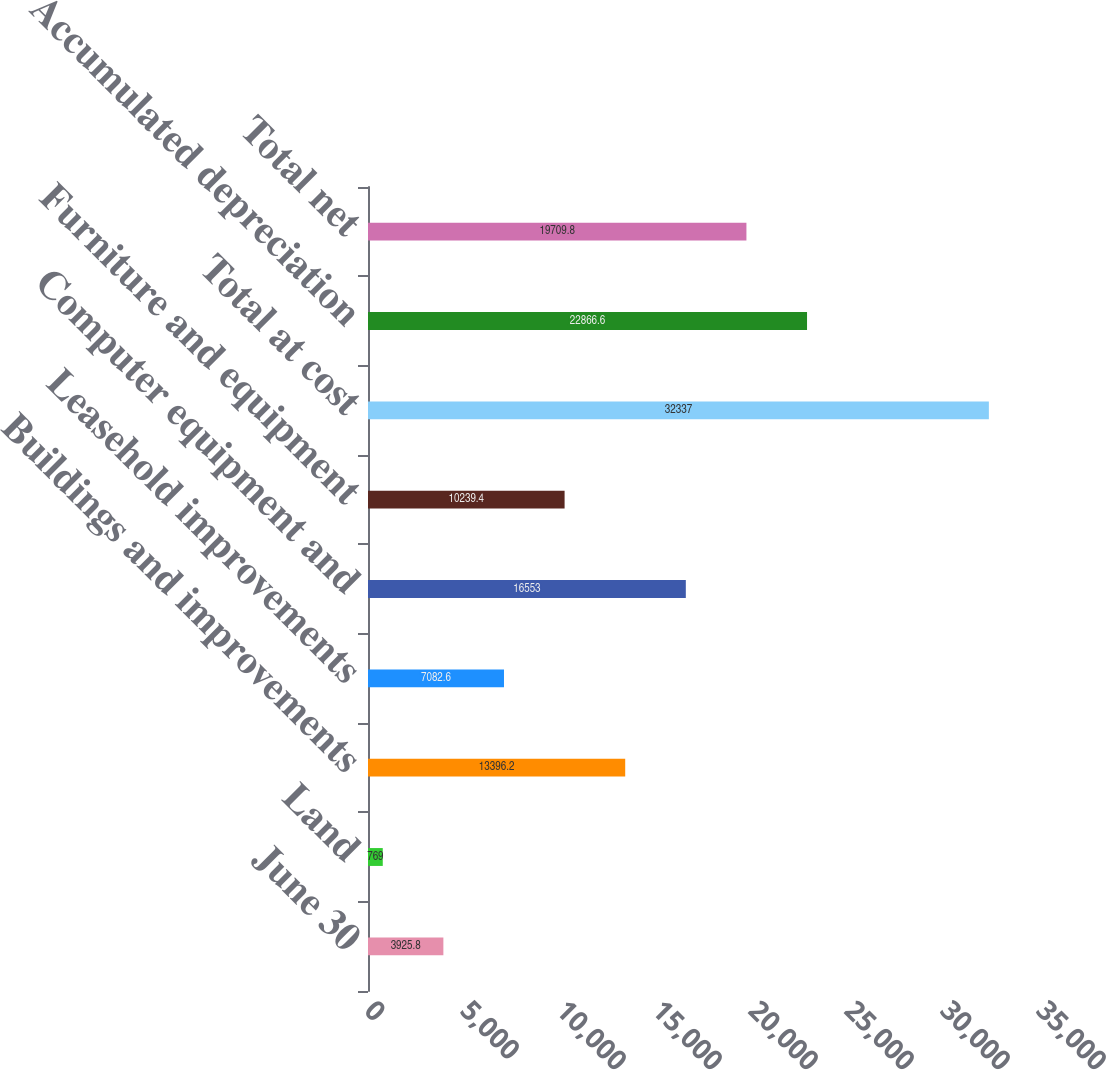Convert chart to OTSL. <chart><loc_0><loc_0><loc_500><loc_500><bar_chart><fcel>June 30<fcel>Land<fcel>Buildings and improvements<fcel>Leasehold improvements<fcel>Computer equipment and<fcel>Furniture and equipment<fcel>Total at cost<fcel>Accumulated depreciation<fcel>Total net<nl><fcel>3925.8<fcel>769<fcel>13396.2<fcel>7082.6<fcel>16553<fcel>10239.4<fcel>32337<fcel>22866.6<fcel>19709.8<nl></chart> 